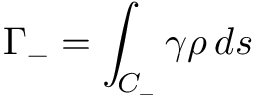Convert formula to latex. <formula><loc_0><loc_0><loc_500><loc_500>\Gamma _ { - } = \int _ { C _ { - } } \gamma \rho \, d s</formula> 